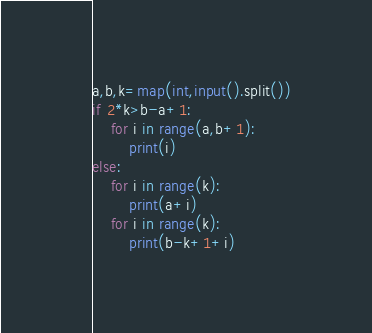<code> <loc_0><loc_0><loc_500><loc_500><_Python_>a,b,k=map(int,input().split())
if 2*k>b-a+1:
    for i in range(a,b+1):
        print(i)
else:
    for i in range(k):
        print(a+i)
    for i in range(k):
        print(b-k+1+i)</code> 